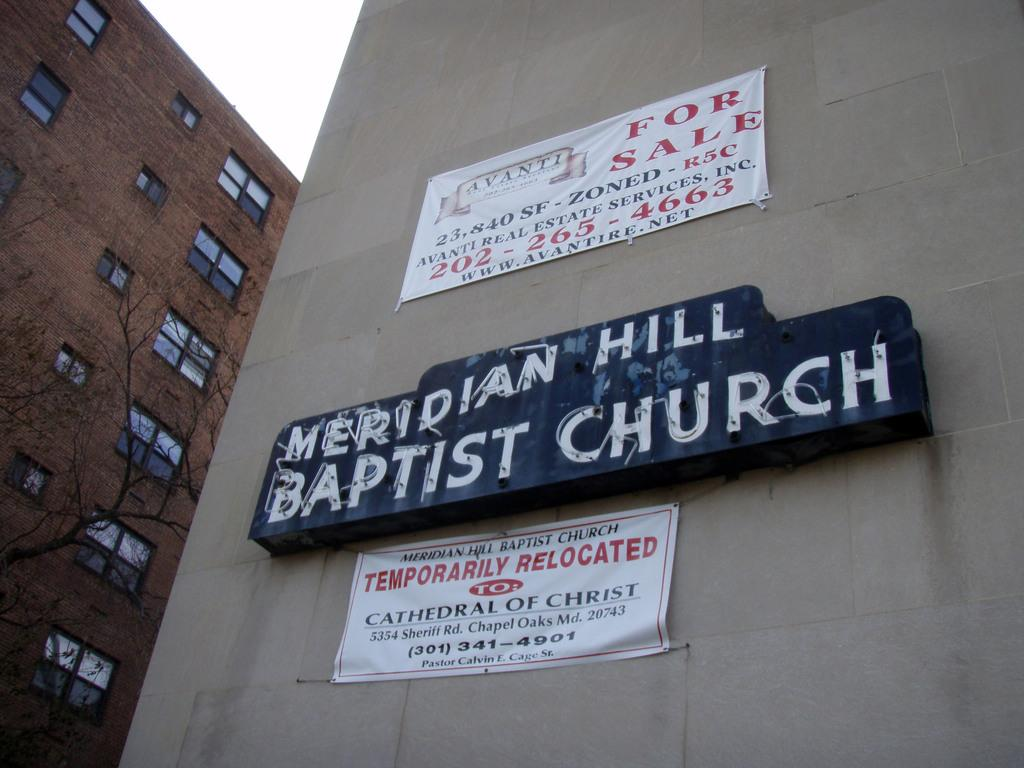What type of vegetation is visible in the image? There are trees in the image. What type of structures can be seen in the image? There are buildings in the image. What is attached to the buildings? There are name boards and banners on the buildings. What type of winter sport is being played in the image? There is no winter sport or any indication of winter in the image. What type of pain relief medication is visible in the image? There is no medication or any indication of pain in the image. 